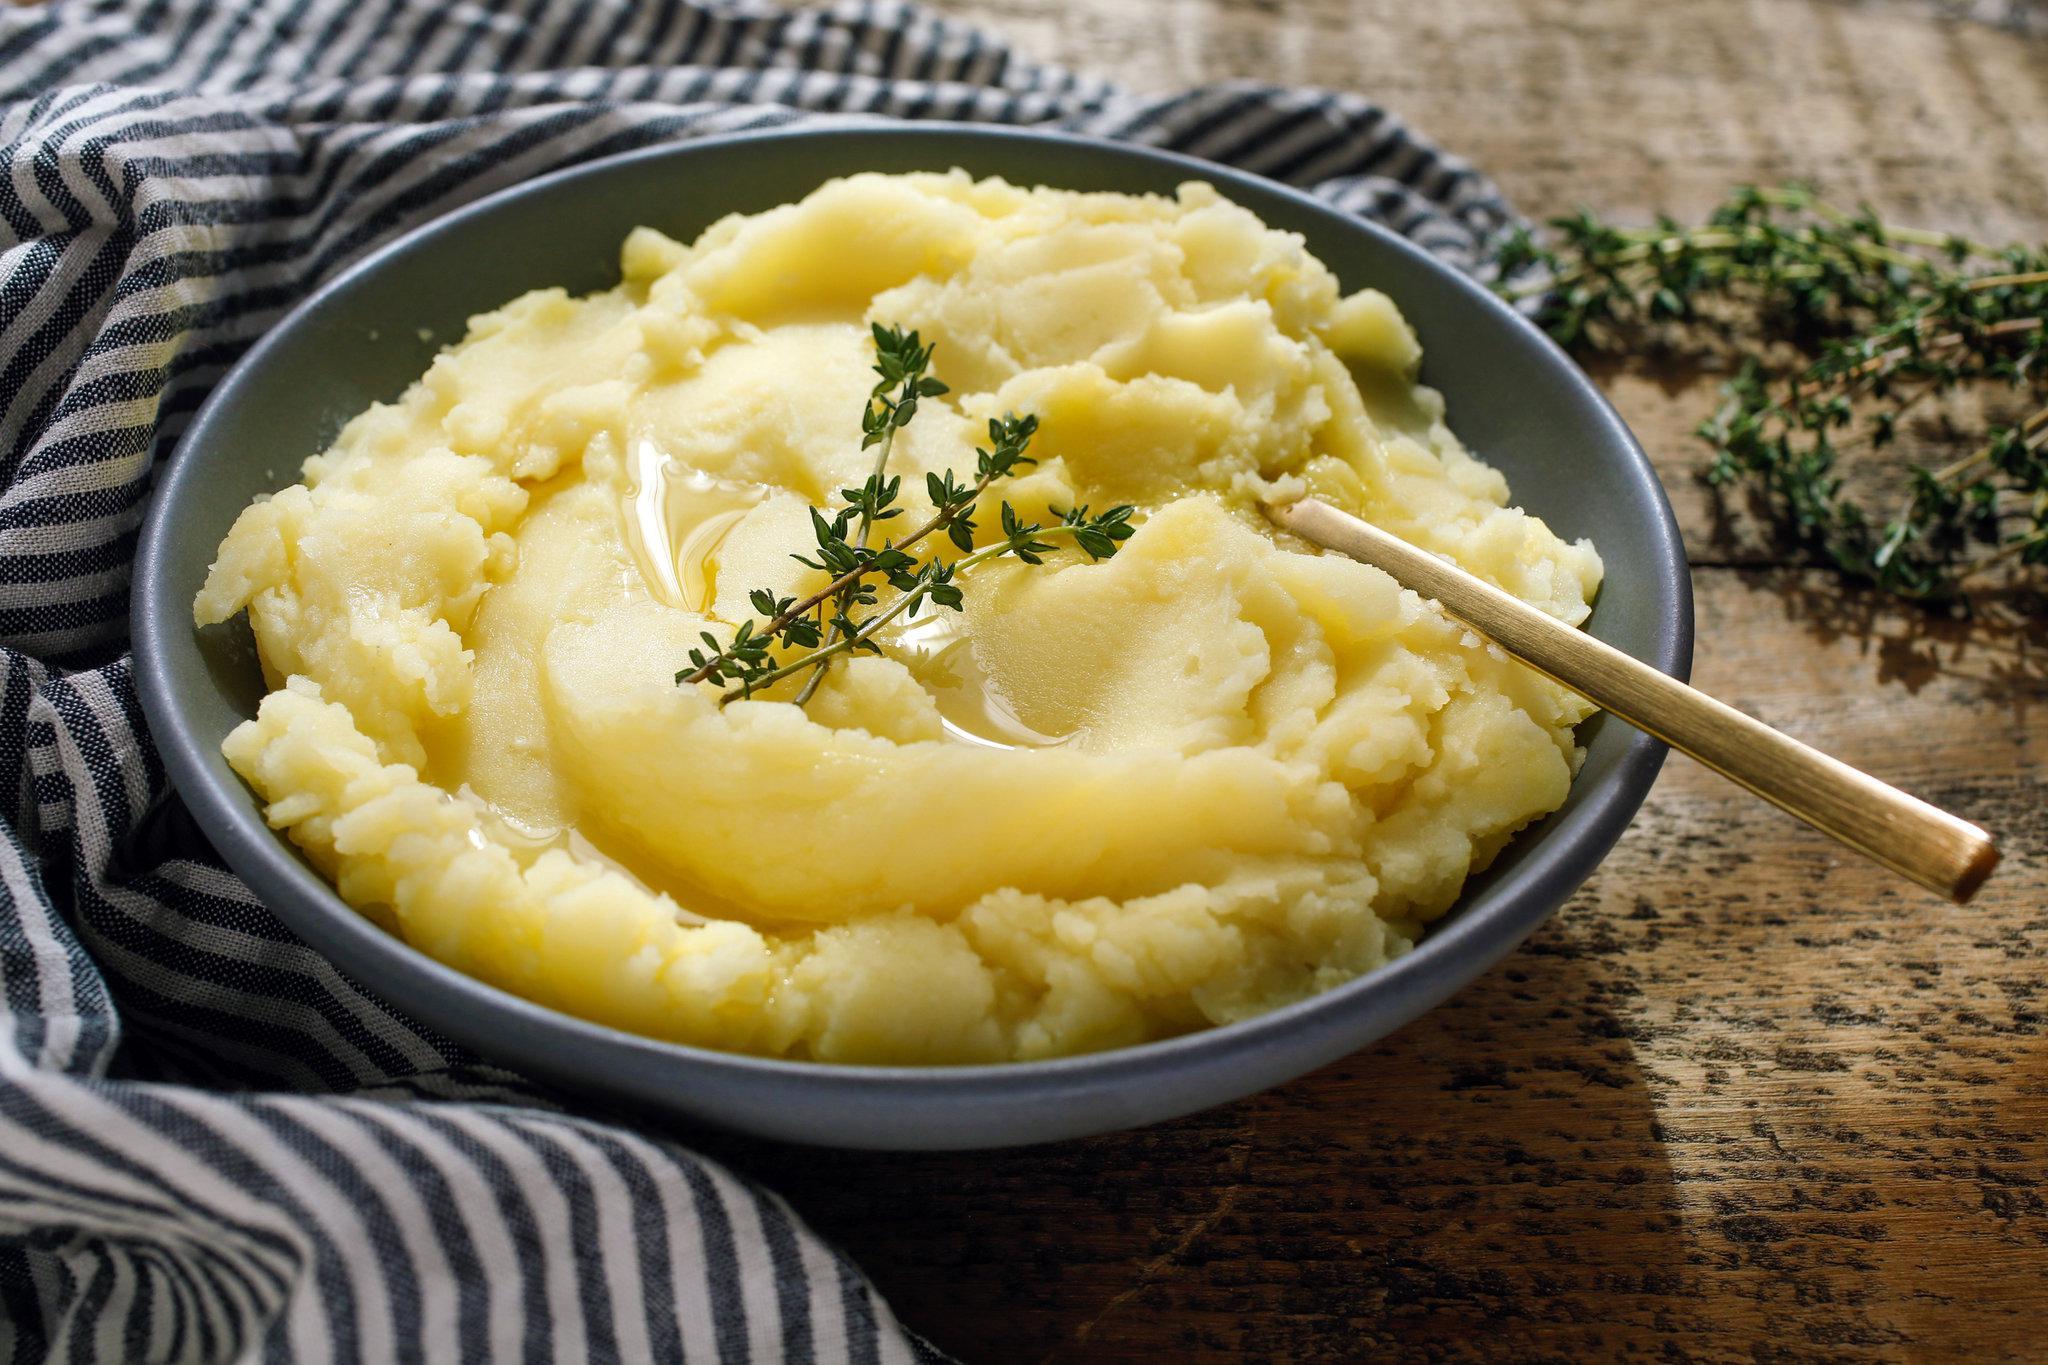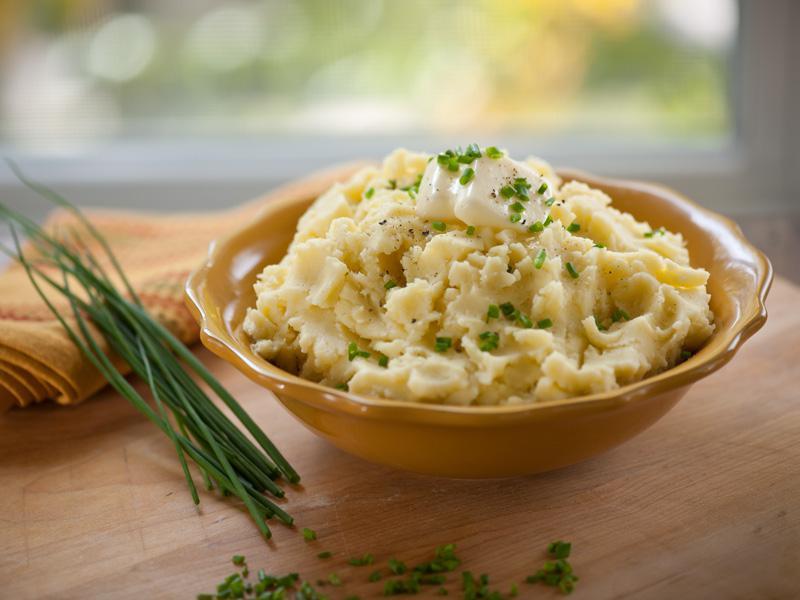The first image is the image on the left, the second image is the image on the right. For the images shown, is this caption "The mashed potato bowl on the right contains a serving utensil." true? Answer yes or no. No. The first image is the image on the left, the second image is the image on the right. Analyze the images presented: Is the assertion "There is one spoon shown." valid? Answer yes or no. Yes. 